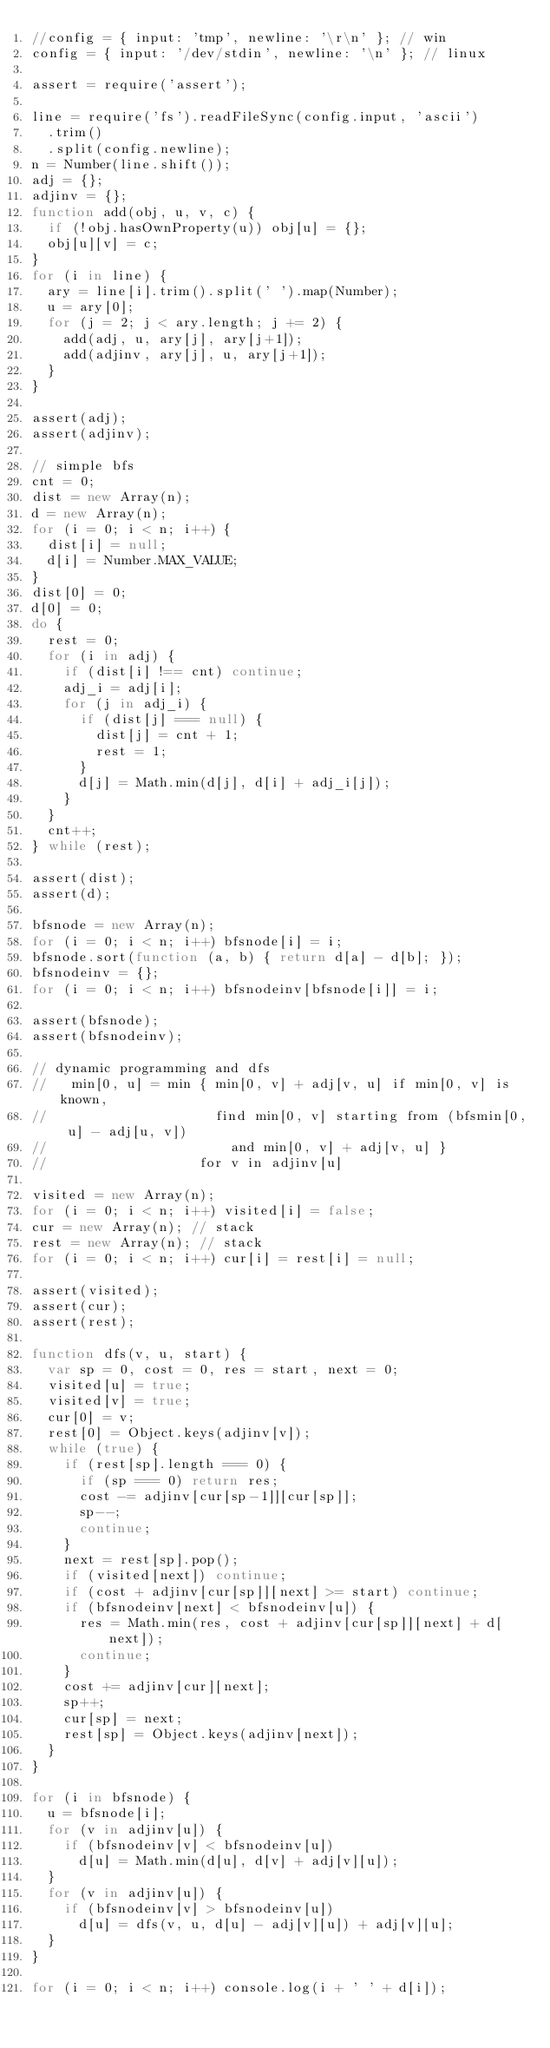<code> <loc_0><loc_0><loc_500><loc_500><_JavaScript_>//config = { input: 'tmp', newline: '\r\n' }; // win
config = { input: '/dev/stdin', newline: '\n' }; // linux

assert = require('assert');

line = require('fs').readFileSync(config.input, 'ascii')
  .trim()
  .split(config.newline);
n = Number(line.shift());
adj = {};
adjinv = {};
function add(obj, u, v, c) {
  if (!obj.hasOwnProperty(u)) obj[u] = {};
  obj[u][v] = c;
}
for (i in line) {
  ary = line[i].trim().split(' ').map(Number);
  u = ary[0];
  for (j = 2; j < ary.length; j += 2) {
    add(adj, u, ary[j], ary[j+1]);
    add(adjinv, ary[j], u, ary[j+1]);
  }
}

assert(adj);
assert(adjinv);

// simple bfs
cnt = 0;
dist = new Array(n);
d = new Array(n);
for (i = 0; i < n; i++) {
  dist[i] = null;
  d[i] = Number.MAX_VALUE;
}
dist[0] = 0;
d[0] = 0;
do {
  rest = 0;
  for (i in adj) {
    if (dist[i] !== cnt) continue;
    adj_i = adj[i];
    for (j in adj_i) {
      if (dist[j] === null) {
        dist[j] = cnt + 1;
        rest = 1;
      }
      d[j] = Math.min(d[j], d[i] + adj_i[j]);
    }
  }
  cnt++;
} while (rest);

assert(dist);
assert(d);

bfsnode = new Array(n);
for (i = 0; i < n; i++) bfsnode[i] = i;
bfsnode.sort(function (a, b) { return d[a] - d[b]; });
bfsnodeinv = {};
for (i = 0; i < n; i++) bfsnodeinv[bfsnode[i]] = i;

assert(bfsnode);
assert(bfsnodeinv);

// dynamic programming and dfs
//   min[0, u] = min { min[0, v] + adj[v, u] if min[0, v] is known,
//                     find min[0, v] starting from (bfsmin[0, u] - adj[u, v])
//                       and min[0, v] + adj[v, u] }
//                   for v in adjinv[u]

visited = new Array(n);
for (i = 0; i < n; i++) visited[i] = false;
cur = new Array(n); // stack
rest = new Array(n); // stack
for (i = 0; i < n; i++) cur[i] = rest[i] = null;

assert(visited);
assert(cur);
assert(rest);

function dfs(v, u, start) {
  var sp = 0, cost = 0, res = start, next = 0;
  visited[u] = true;
  visited[v] = true;
  cur[0] = v;
  rest[0] = Object.keys(adjinv[v]);
  while (true) {
    if (rest[sp].length === 0) {
      if (sp === 0) return res;
      cost -= adjinv[cur[sp-1]][cur[sp]];
      sp--;
      continue;
    }
    next = rest[sp].pop();
    if (visited[next]) continue;
    if (cost + adjinv[cur[sp]][next] >= start) continue;
    if (bfsnodeinv[next] < bfsnodeinv[u]) {
      res = Math.min(res, cost + adjinv[cur[sp]][next] + d[next]);
      continue;
    }
    cost += adjinv[cur][next];
    sp++;
    cur[sp] = next;
    rest[sp] = Object.keys(adjinv[next]);
  }
}

for (i in bfsnode) {
  u = bfsnode[i];
  for (v in adjinv[u]) {
    if (bfsnodeinv[v] < bfsnodeinv[u])
      d[u] = Math.min(d[u], d[v] + adj[v][u]);
  }
  for (v in adjinv[u]) {
    if (bfsnodeinv[v] > bfsnodeinv[u])
      d[u] = dfs(v, u, d[u] - adj[v][u]) + adj[v][u];
  }
}

for (i = 0; i < n; i++) console.log(i + ' ' + d[i]);</code> 